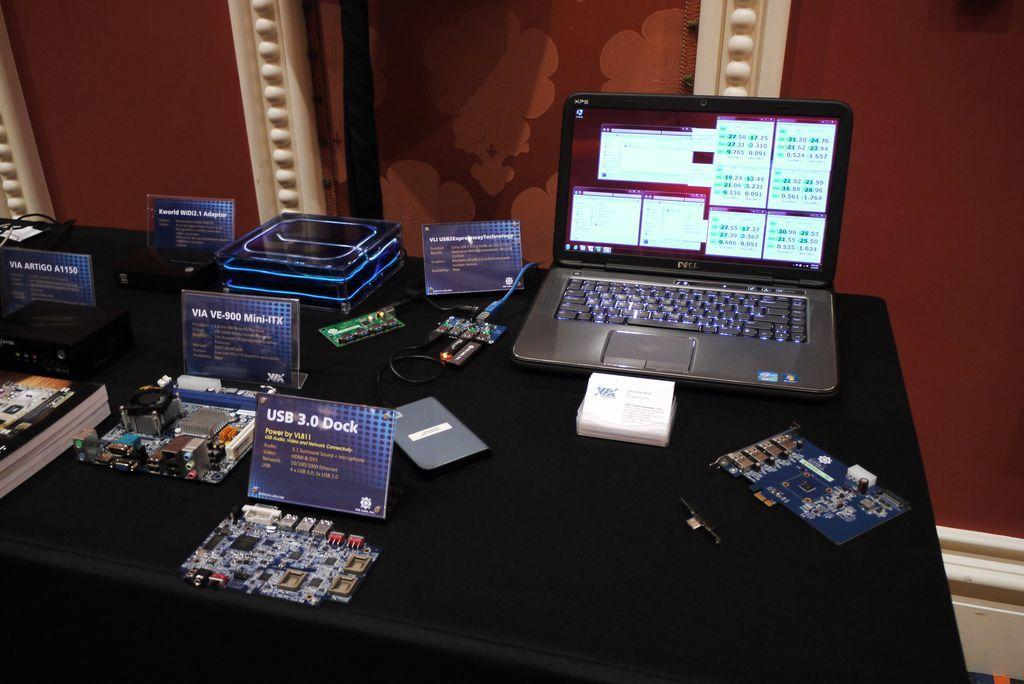<image>
Summarize the visual content of the image. A table filled with electronics and of the lighted screens, one of them is showing USB 3.0 Dock. 